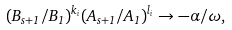<formula> <loc_0><loc_0><loc_500><loc_500>( B _ { s + 1 } / B _ { 1 } ) ^ { k _ { i } } ( A _ { s + 1 } / A _ { 1 } ) ^ { l _ { i } } \rightarrow - \alpha / \omega ,</formula> 